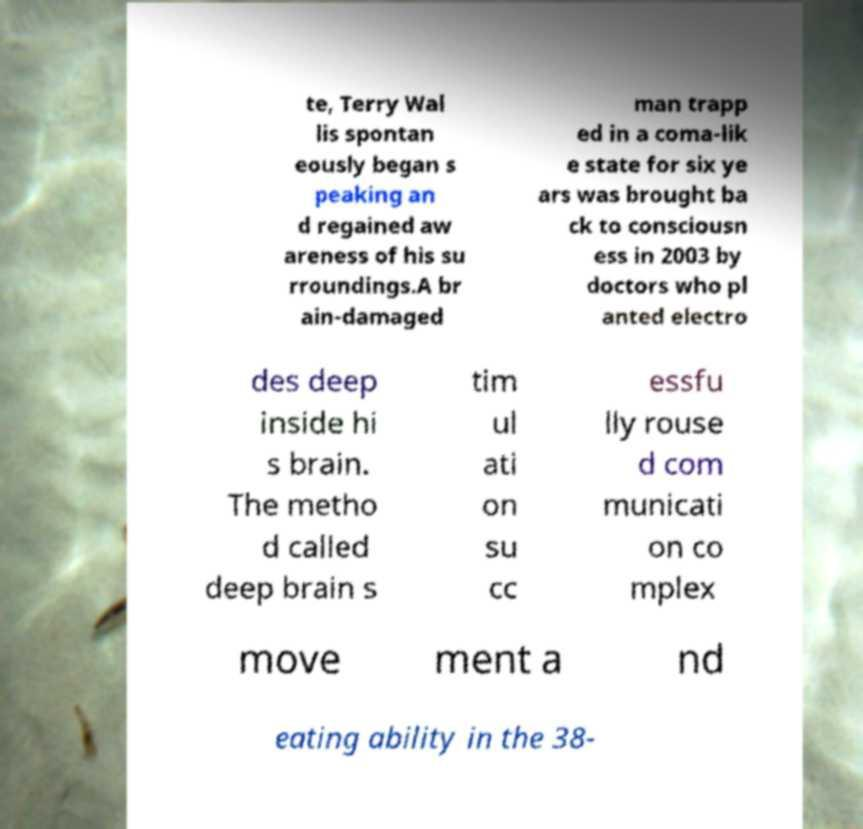Can you read and provide the text displayed in the image?This photo seems to have some interesting text. Can you extract and type it out for me? te, Terry Wal lis spontan eously began s peaking an d regained aw areness of his su rroundings.A br ain-damaged man trapp ed in a coma-lik e state for six ye ars was brought ba ck to consciousn ess in 2003 by doctors who pl anted electro des deep inside hi s brain. The metho d called deep brain s tim ul ati on su cc essfu lly rouse d com municati on co mplex move ment a nd eating ability in the 38- 